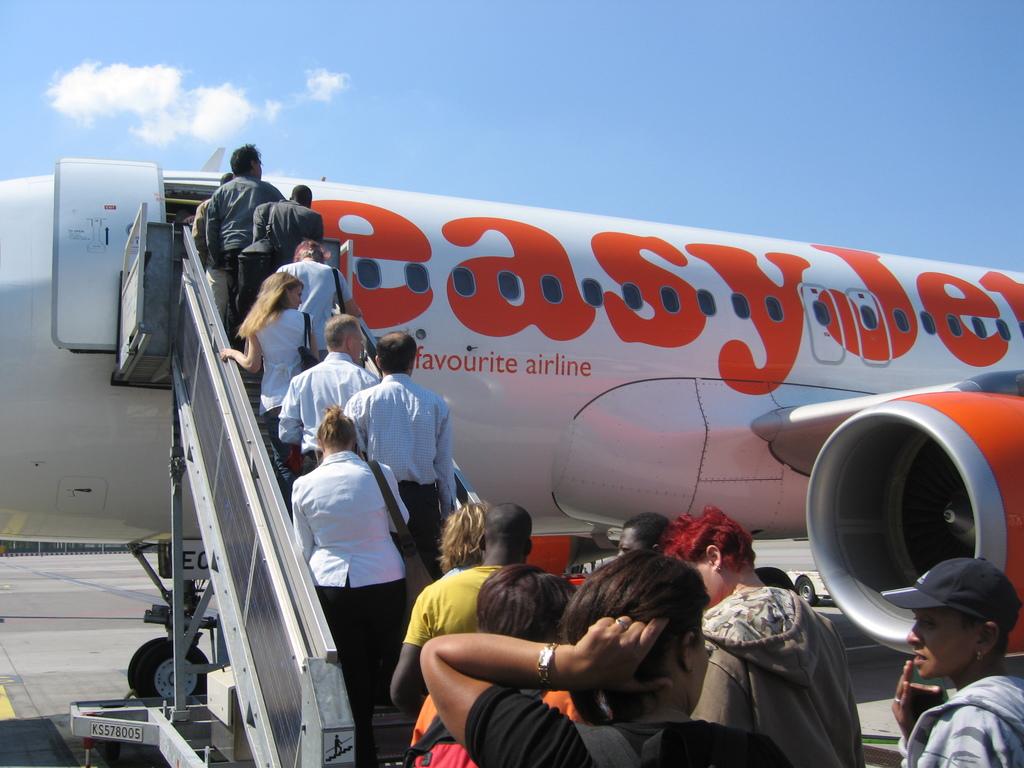What is the name of the company near the right shoulder of this player?
Give a very brief answer. Easyjet. What is the name of the flight?
Offer a terse response. Easyjet. 